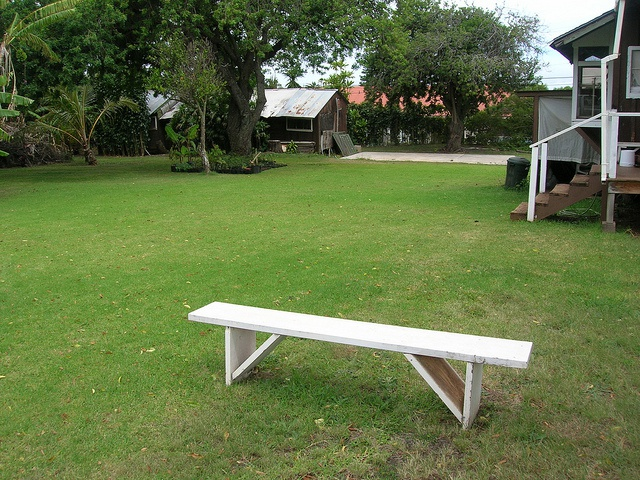Describe the objects in this image and their specific colors. I can see a bench in darkgreen, white, gray, darkgray, and olive tones in this image. 